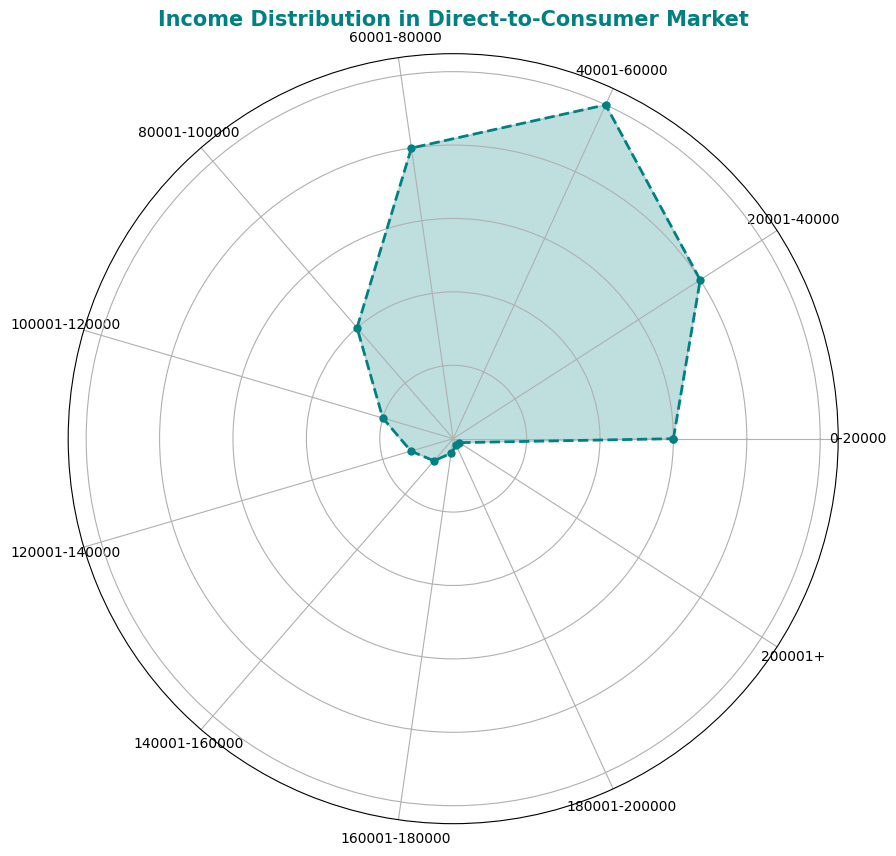What's the most common income range among consumers in this direct-to-consumer market? The largest segment of the chart represents consumers with income in the range of 40,001-60,000, filling up the most area in the rose chart.
Answer: 40,001-60,000 Which income range has the smallest percentage of consumers? The smallest segments of the chart, almost negligible, are for the income ranges of 180,001-200,000 and 200,001+, making up 0.5% each.
Answer: 180,001-200,000 and 200,001+ What's the total percentage of consumers earning 100,000 or more? To find the total percentage of consumers earning 100,000 or more, sum the percentages of the segments: 5% (100,001-120,000) + 3% (120,001-140,000) + 2% (140,001-160,000) + 1% (160,001-180,000) + 0.5% (180,001-200,000) + 0.5% (200,001+).
Answer: 12% Compare the percentage of consumers in the 40,001-60,000 range with those in the 60,001-80,000 range. The 40,001-60,000 range comprises 25% of consumers, while the 60,001-80,000 range comprises 20%. Therefore, the 40,001-60,000 range has a higher percentage.
Answer: 40,001-60,000 range is higher What is the difference in percentage between the highest and lowest income groups? The highest percentage is 25% (40,001-60,000), and the lowest is 0.5% for two income ranges (180,001-200,000 and 200,001+). The difference is calculated as 25% - 0.5% = 24.5%.
Answer: 24.5% How much more percentage do consumers in the 0-20,000 range represent compared to those in the 80,001-100,000 range? The 0-20,000 range represents 15%, and the 80,001-100,000 range represents 10%. The difference is 15% - 10% = 5%.
Answer: 5% What's the combined percentage of consumers in the income ranges 20,001-40,000 and 60,001-80,000? Sum the two percentages: 20% (20,001-40,000) + 20% (60,001-80,000) = 40%.
Answer: 40% Identify income ranges where each segment has a visually noticeable difference in area compared to the next higher income range. The chart shows discernible differences between segments 60,001-80,000 (20%) and 80,001-100,000 (10%), as well as 100,001-120,000 (5%) and 120,001-140,000 (3%), where the visual length of the segments notably decreases.
Answer: 60,001-80,000 vs. 80,001-100,000 and 100,001-120,000 vs. 120,001-140,000 Which two income ranges together make up a quarter (25%) of the consumer population? The 0-20,000 range and 20,001-40,000 range together make up 15% + 20% = 35%. However, the 60,001-80,000 range (20%) and the 80,001-100,000 range (10%) together make up 30%, while 40,001-60,000 (25%) makes up a quarter on its own. Another pair making up 25% precisely are the ranges 20,001-40,000 (20%) and 80,001-100,000 (10%).
Answer: 20,001-40,000 and 80,001-100,000 